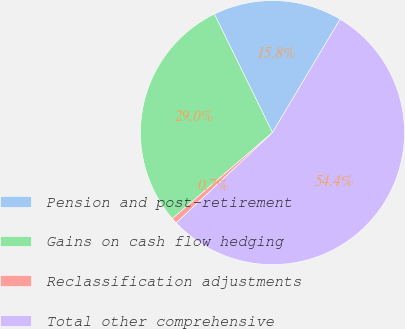Convert chart. <chart><loc_0><loc_0><loc_500><loc_500><pie_chart><fcel>Pension and post-retirement<fcel>Gains on cash flow hedging<fcel>Reclassification adjustments<fcel>Total other comprehensive<nl><fcel>15.82%<fcel>29.04%<fcel>0.7%<fcel>54.44%<nl></chart> 